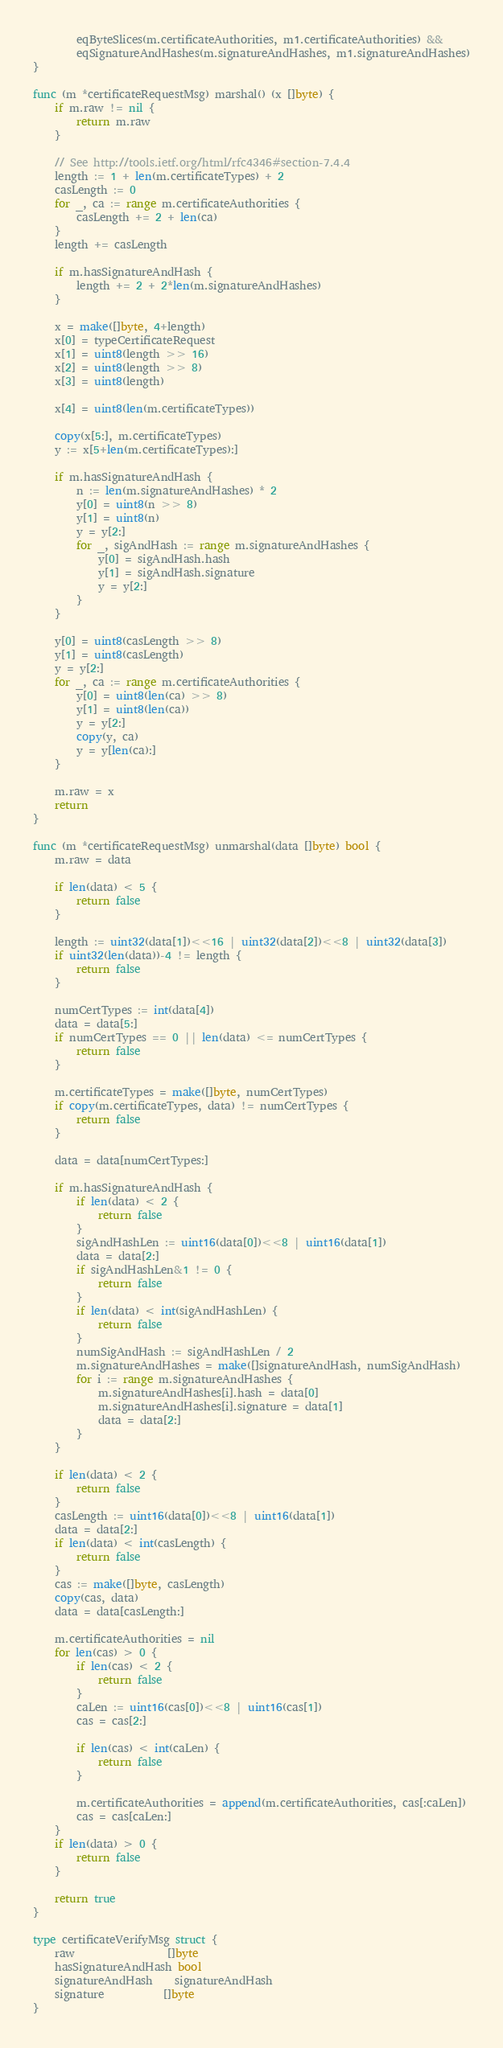<code> <loc_0><loc_0><loc_500><loc_500><_Go_>		eqByteSlices(m.certificateAuthorities, m1.certificateAuthorities) &&
		eqSignatureAndHashes(m.signatureAndHashes, m1.signatureAndHashes)
}

func (m *certificateRequestMsg) marshal() (x []byte) {
	if m.raw != nil {
		return m.raw
	}

	// See http://tools.ietf.org/html/rfc4346#section-7.4.4
	length := 1 + len(m.certificateTypes) + 2
	casLength := 0
	for _, ca := range m.certificateAuthorities {
		casLength += 2 + len(ca)
	}
	length += casLength

	if m.hasSignatureAndHash {
		length += 2 + 2*len(m.signatureAndHashes)
	}

	x = make([]byte, 4+length)
	x[0] = typeCertificateRequest
	x[1] = uint8(length >> 16)
	x[2] = uint8(length >> 8)
	x[3] = uint8(length)

	x[4] = uint8(len(m.certificateTypes))

	copy(x[5:], m.certificateTypes)
	y := x[5+len(m.certificateTypes):]

	if m.hasSignatureAndHash {
		n := len(m.signatureAndHashes) * 2
		y[0] = uint8(n >> 8)
		y[1] = uint8(n)
		y = y[2:]
		for _, sigAndHash := range m.signatureAndHashes {
			y[0] = sigAndHash.hash
			y[1] = sigAndHash.signature
			y = y[2:]
		}
	}

	y[0] = uint8(casLength >> 8)
	y[1] = uint8(casLength)
	y = y[2:]
	for _, ca := range m.certificateAuthorities {
		y[0] = uint8(len(ca) >> 8)
		y[1] = uint8(len(ca))
		y = y[2:]
		copy(y, ca)
		y = y[len(ca):]
	}

	m.raw = x
	return
}

func (m *certificateRequestMsg) unmarshal(data []byte) bool {
	m.raw = data

	if len(data) < 5 {
		return false
	}

	length := uint32(data[1])<<16 | uint32(data[2])<<8 | uint32(data[3])
	if uint32(len(data))-4 != length {
		return false
	}

	numCertTypes := int(data[4])
	data = data[5:]
	if numCertTypes == 0 || len(data) <= numCertTypes {
		return false
	}

	m.certificateTypes = make([]byte, numCertTypes)
	if copy(m.certificateTypes, data) != numCertTypes {
		return false
	}

	data = data[numCertTypes:]

	if m.hasSignatureAndHash {
		if len(data) < 2 {
			return false
		}
		sigAndHashLen := uint16(data[0])<<8 | uint16(data[1])
		data = data[2:]
		if sigAndHashLen&1 != 0 {
			return false
		}
		if len(data) < int(sigAndHashLen) {
			return false
		}
		numSigAndHash := sigAndHashLen / 2
		m.signatureAndHashes = make([]signatureAndHash, numSigAndHash)
		for i := range m.signatureAndHashes {
			m.signatureAndHashes[i].hash = data[0]
			m.signatureAndHashes[i].signature = data[1]
			data = data[2:]
		}
	}

	if len(data) < 2 {
		return false
	}
	casLength := uint16(data[0])<<8 | uint16(data[1])
	data = data[2:]
	if len(data) < int(casLength) {
		return false
	}
	cas := make([]byte, casLength)
	copy(cas, data)
	data = data[casLength:]

	m.certificateAuthorities = nil
	for len(cas) > 0 {
		if len(cas) < 2 {
			return false
		}
		caLen := uint16(cas[0])<<8 | uint16(cas[1])
		cas = cas[2:]

		if len(cas) < int(caLen) {
			return false
		}

		m.certificateAuthorities = append(m.certificateAuthorities, cas[:caLen])
		cas = cas[caLen:]
	}
	if len(data) > 0 {
		return false
	}

	return true
}

type certificateVerifyMsg struct {
	raw                 []byte
	hasSignatureAndHash bool
	signatureAndHash    signatureAndHash
	signature           []byte
}
</code> 